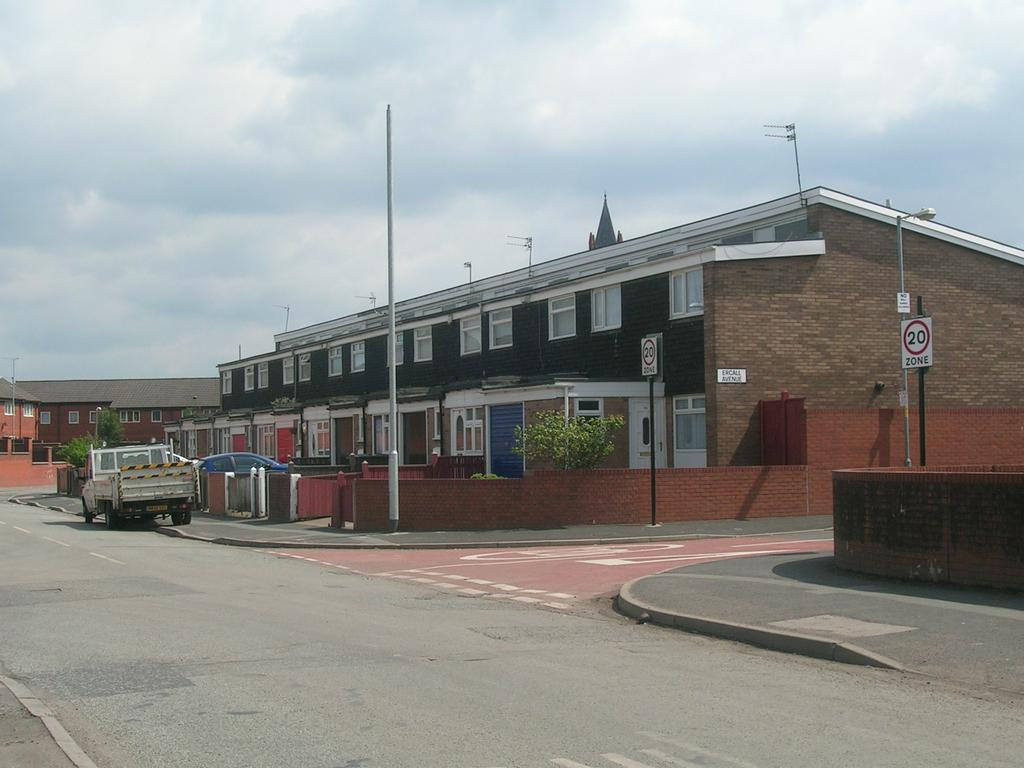What types of objects are on the ground in the image? There are vehicles on the ground in the image. What other objects can be seen in the image besides vehicles? There are boards, poles, buildings, trees, and a road in the image. What is visible at the top of the image? The sky is visible at the top of the image. How many snakes are slithering on the road in the image? There are no snakes present in the image; it features vehicles, boards, poles, buildings, trees, and a road. What type of butter is being used to grease the poles in the image? There is no butter present in the image, nor are the poles being greased. 